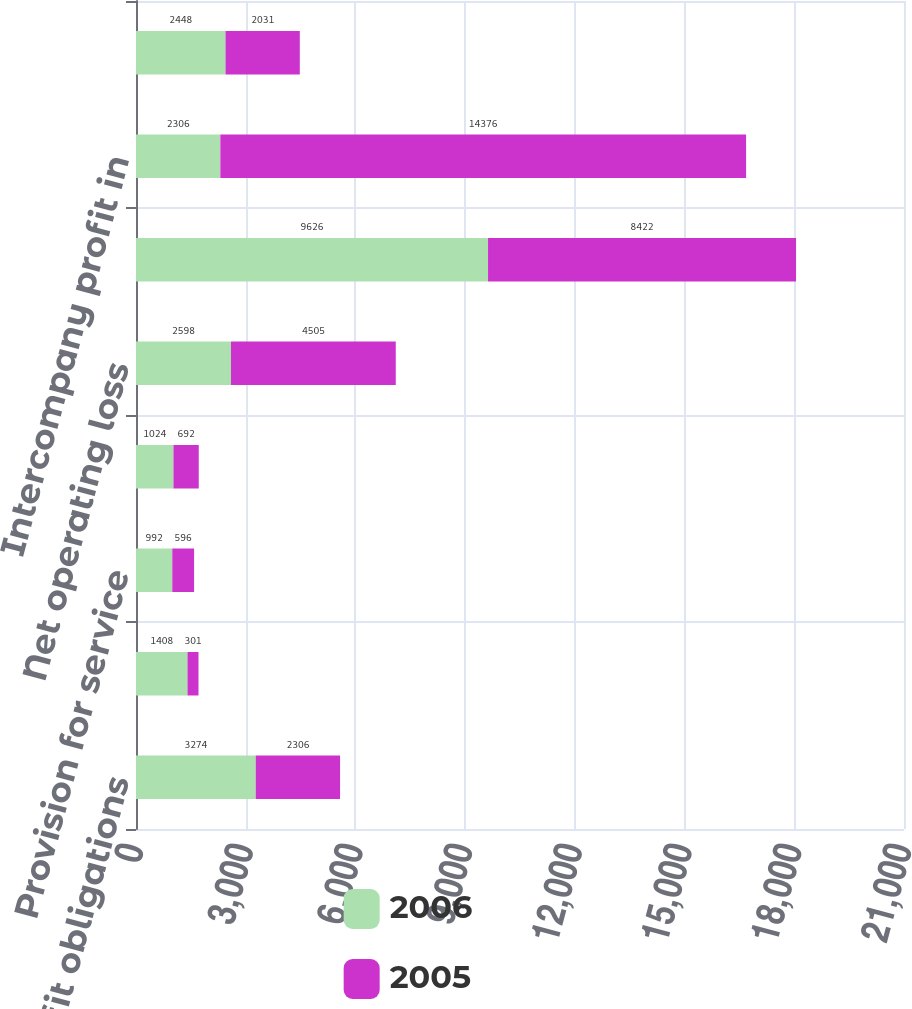<chart> <loc_0><loc_0><loc_500><loc_500><stacked_bar_chart><ecel><fcel>Employee benefit obligations<fcel>Inventory<fcel>Provision for service<fcel>Provision for doubtful debts<fcel>Net operating loss<fcel>Foreign tax credits<fcel>Intercompany profit in<fcel>Other<nl><fcel>2006<fcel>3274<fcel>1408<fcel>992<fcel>1024<fcel>2598<fcel>9626<fcel>2306<fcel>2448<nl><fcel>2005<fcel>2306<fcel>301<fcel>596<fcel>692<fcel>4505<fcel>8422<fcel>14376<fcel>2031<nl></chart> 